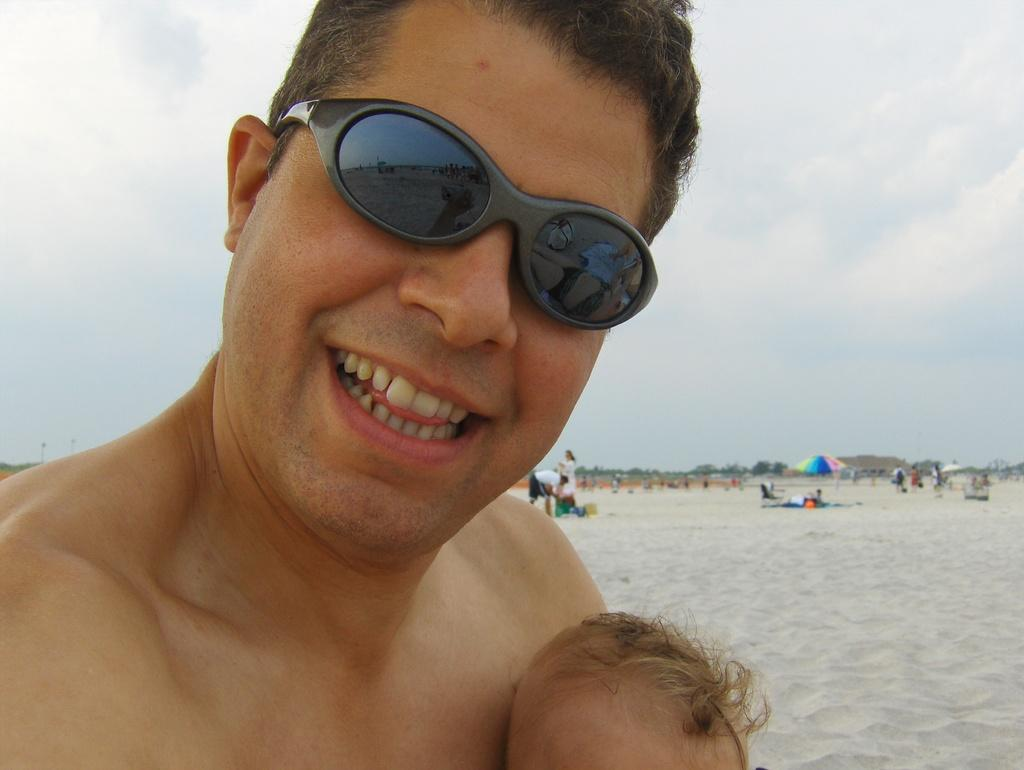What is the person in the image wearing on their face? The person in the image is wearing spectacles. Can you describe the other people visible in the image? There are other people visible in the image, but their specific features are not mentioned in the provided facts. What objects are present in the image that might be used for protection from the elements? Umbrellas are present in the image for protection from the elements. What month is it in the image? The provided facts do not mention the month, so it cannot be determined from the image. What type of education is the person in the image pursuing? The provided facts do not mention any educational pursuits, so it cannot be determined from the image. 